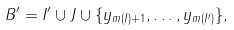Convert formula to latex. <formula><loc_0><loc_0><loc_500><loc_500>B ^ { \prime } = I ^ { \prime } \cup J \cup \{ y _ { m ( I ) + 1 } , \dots , y _ { m ( I ^ { \prime } ) } \} ,</formula> 